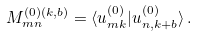<formula> <loc_0><loc_0><loc_500><loc_500>M _ { m n } ^ { ( 0 ) ( k , b ) } = \langle u _ { m k } ^ { ( 0 ) } | u _ { n , k + b } ^ { ( 0 ) } \rangle \, .</formula> 